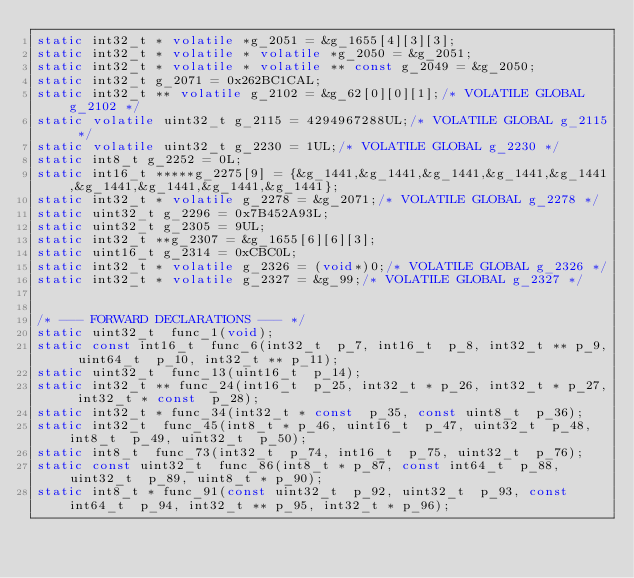Convert code to text. <code><loc_0><loc_0><loc_500><loc_500><_C_>static int32_t * volatile *g_2051 = &g_1655[4][3][3];
static int32_t * volatile * volatile *g_2050 = &g_2051;
static int32_t * volatile * volatile ** const g_2049 = &g_2050;
static int32_t g_2071 = 0x262BC1CAL;
static int32_t ** volatile g_2102 = &g_62[0][0][1];/* VOLATILE GLOBAL g_2102 */
static volatile uint32_t g_2115 = 4294967288UL;/* VOLATILE GLOBAL g_2115 */
static volatile uint32_t g_2230 = 1UL;/* VOLATILE GLOBAL g_2230 */
static int8_t g_2252 = 0L;
static int16_t *****g_2275[9] = {&g_1441,&g_1441,&g_1441,&g_1441,&g_1441,&g_1441,&g_1441,&g_1441,&g_1441};
static int32_t * volatile g_2278 = &g_2071;/* VOLATILE GLOBAL g_2278 */
static uint32_t g_2296 = 0x7B452A93L;
static uint32_t g_2305 = 9UL;
static int32_t **g_2307 = &g_1655[6][6][3];
static uint16_t g_2314 = 0xCBC0L;
static int32_t * volatile g_2326 = (void*)0;/* VOLATILE GLOBAL g_2326 */
static int32_t * volatile g_2327 = &g_99;/* VOLATILE GLOBAL g_2327 */


/* --- FORWARD DECLARATIONS --- */
static uint32_t  func_1(void);
static const int16_t  func_6(int32_t  p_7, int16_t  p_8, int32_t ** p_9, uint64_t  p_10, int32_t ** p_11);
static uint32_t  func_13(uint16_t  p_14);
static int32_t ** func_24(int16_t  p_25, int32_t * p_26, int32_t * p_27, int32_t * const  p_28);
static int32_t * func_34(int32_t * const  p_35, const uint8_t  p_36);
static int32_t  func_45(int8_t * p_46, uint16_t  p_47, uint32_t  p_48, int8_t  p_49, uint32_t  p_50);
static int8_t  func_73(int32_t  p_74, int16_t  p_75, uint32_t  p_76);
static const uint32_t  func_86(int8_t * p_87, const int64_t  p_88, uint32_t  p_89, uint8_t * p_90);
static int8_t * func_91(const uint32_t  p_92, uint32_t  p_93, const int64_t  p_94, int32_t ** p_95, int32_t * p_96);</code> 